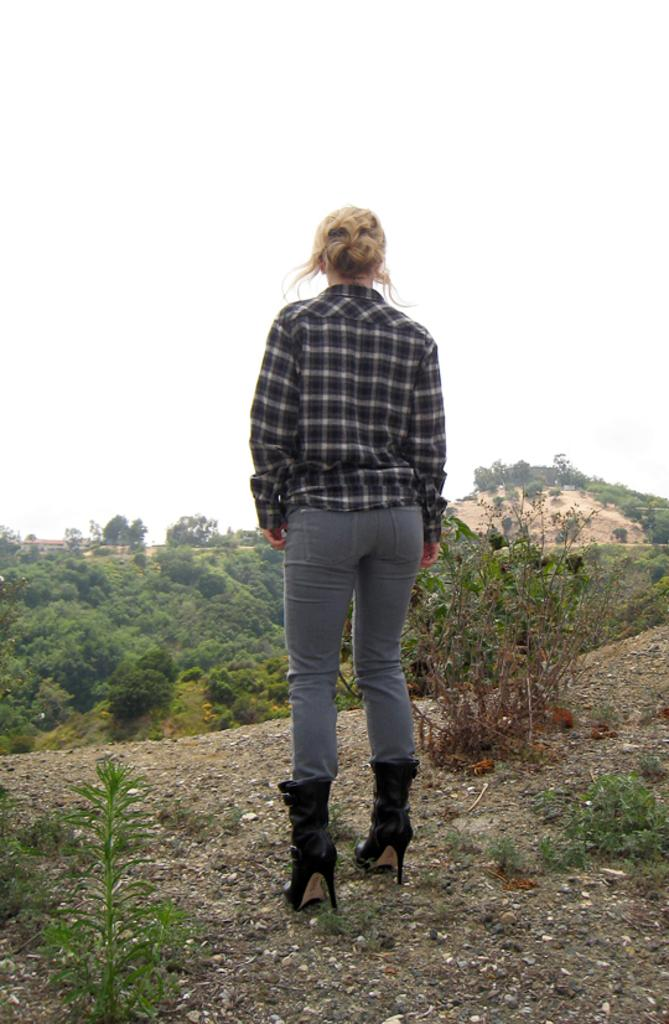What is the main subject in the center of the picture? There is a woman standing in the center of the picture. What can be seen in the foreground of the image? There are plants and stones in the foreground. What is visible in the background of the image? There are trees and a hill in the background. How would you describe the sky in the image? The sky is cloudy in the image. What type of coat is the police officer wearing in the image? There is no police officer or coat present in the image. 